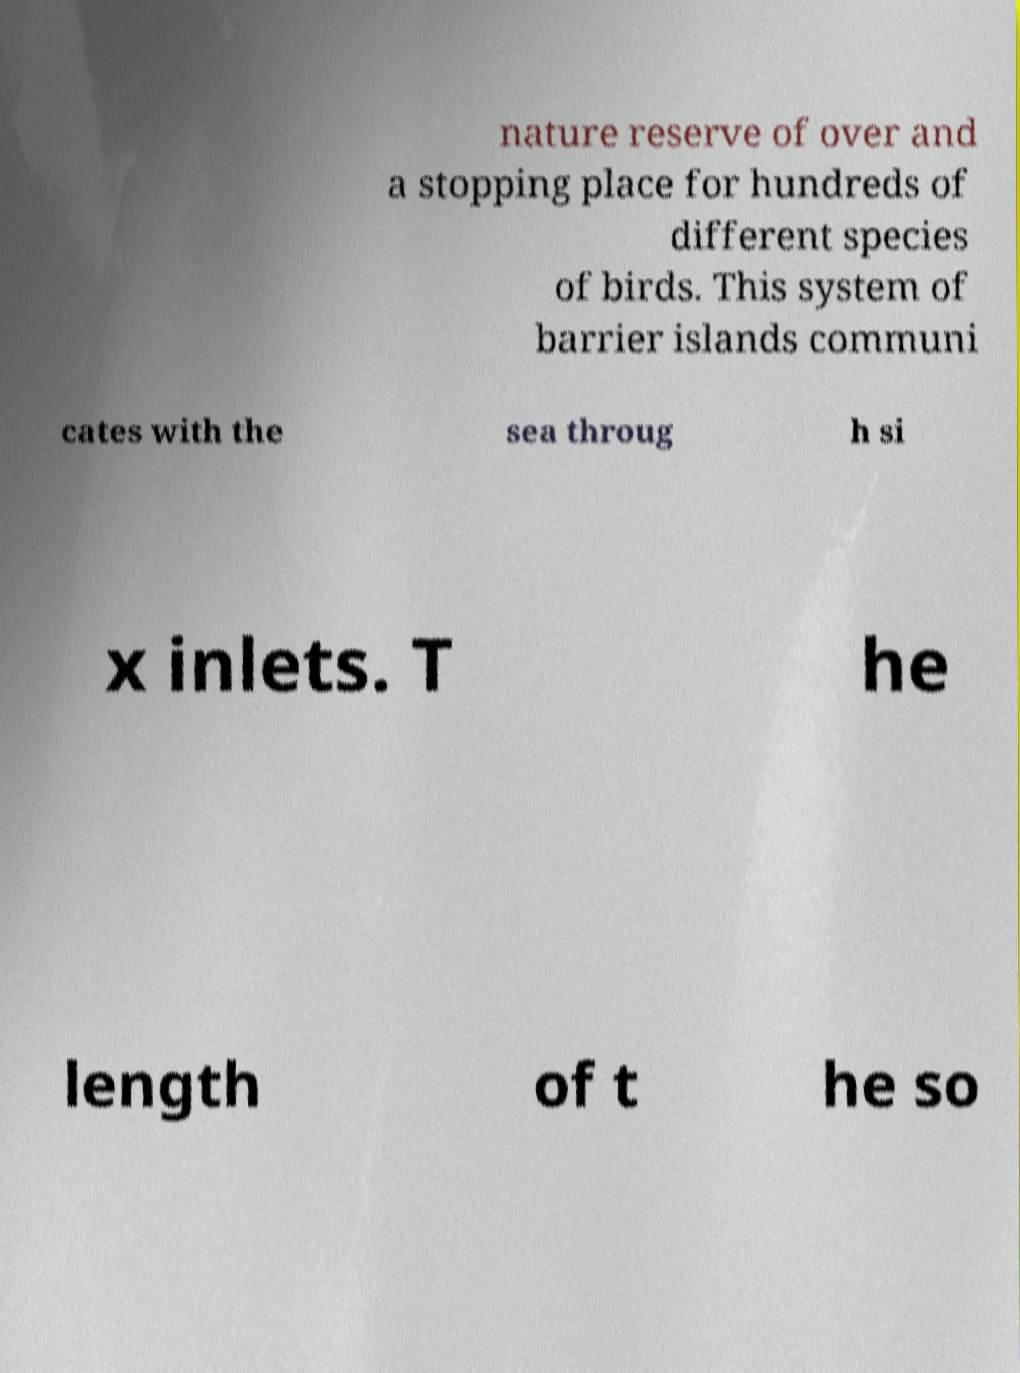Please identify and transcribe the text found in this image. nature reserve of over and a stopping place for hundreds of different species of birds. This system of barrier islands communi cates with the sea throug h si x inlets. T he length of t he so 